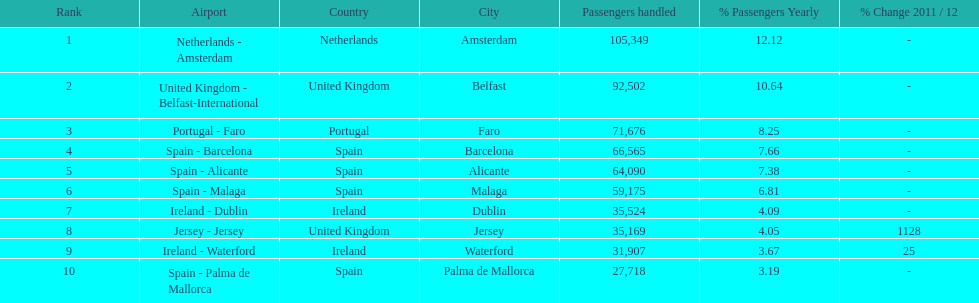How many passengers are going to or coming from spain? 217,548. 